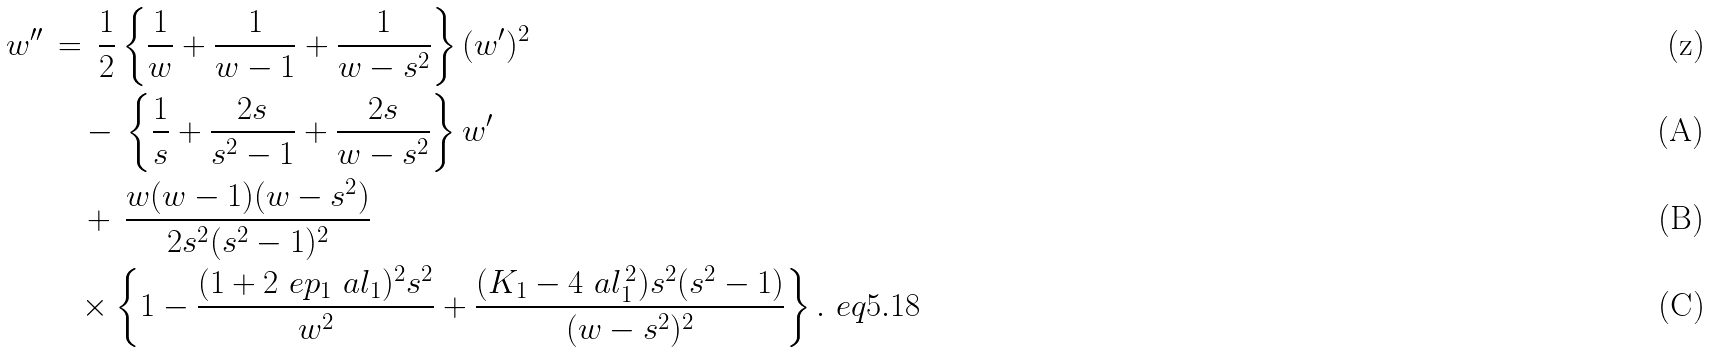<formula> <loc_0><loc_0><loc_500><loc_500>w ^ { \prime \prime } & \, = \, \frac { 1 } { 2 } \left \{ \frac { 1 } { w } + \frac { 1 } { w - 1 } + \frac { 1 } { w - s ^ { 2 } } \right \} ( w ^ { \prime } ) ^ { 2 } \\ & \quad \null \, - \, \left \{ \frac { 1 } { s } + \frac { 2 s } { s ^ { 2 } - 1 } + \frac { 2 s } { w - s ^ { 2 } } \right \} w ^ { \prime } \\ & \quad \null \, + \, \frac { w ( w - 1 ) ( w - s ^ { 2 } ) } { 2 s ^ { 2 } ( s ^ { 2 } - 1 ) ^ { 2 } } \\ & \quad \null \times \left \{ 1 - \frac { ( 1 + 2 \ e p _ { 1 } \ a l _ { 1 } ) ^ { 2 } s ^ { 2 } } { w ^ { 2 } } + \frac { ( K _ { 1 } - 4 \ a l _ { 1 } ^ { \, 2 } ) s ^ { 2 } ( s ^ { 2 } - 1 ) } { ( w - s ^ { 2 } ) ^ { 2 } } \right \} . \ e q { 5 . 1 8 }</formula> 